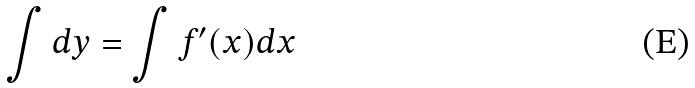Convert formula to latex. <formula><loc_0><loc_0><loc_500><loc_500>\int d y = \int f ^ { \prime } ( x ) d x</formula> 